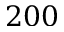<formula> <loc_0><loc_0><loc_500><loc_500>2 0 0</formula> 